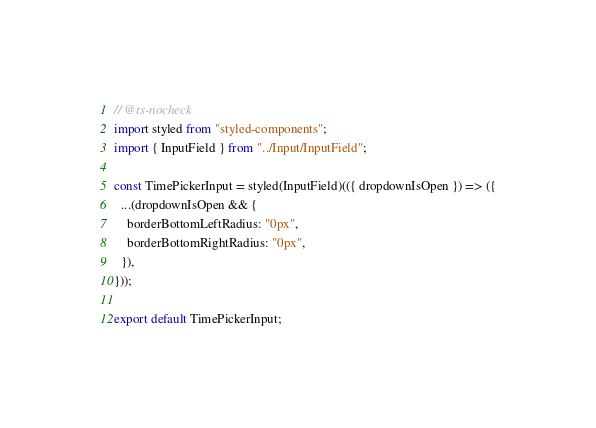Convert code to text. <code><loc_0><loc_0><loc_500><loc_500><_TypeScript_>// @ts-nocheck
import styled from "styled-components";
import { InputField } from "../Input/InputField";

const TimePickerInput = styled(InputField)(({ dropdownIsOpen }) => ({
  ...(dropdownIsOpen && {
    borderBottomLeftRadius: "0px",
    borderBottomRightRadius: "0px",
  }),
}));

export default TimePickerInput;
</code> 